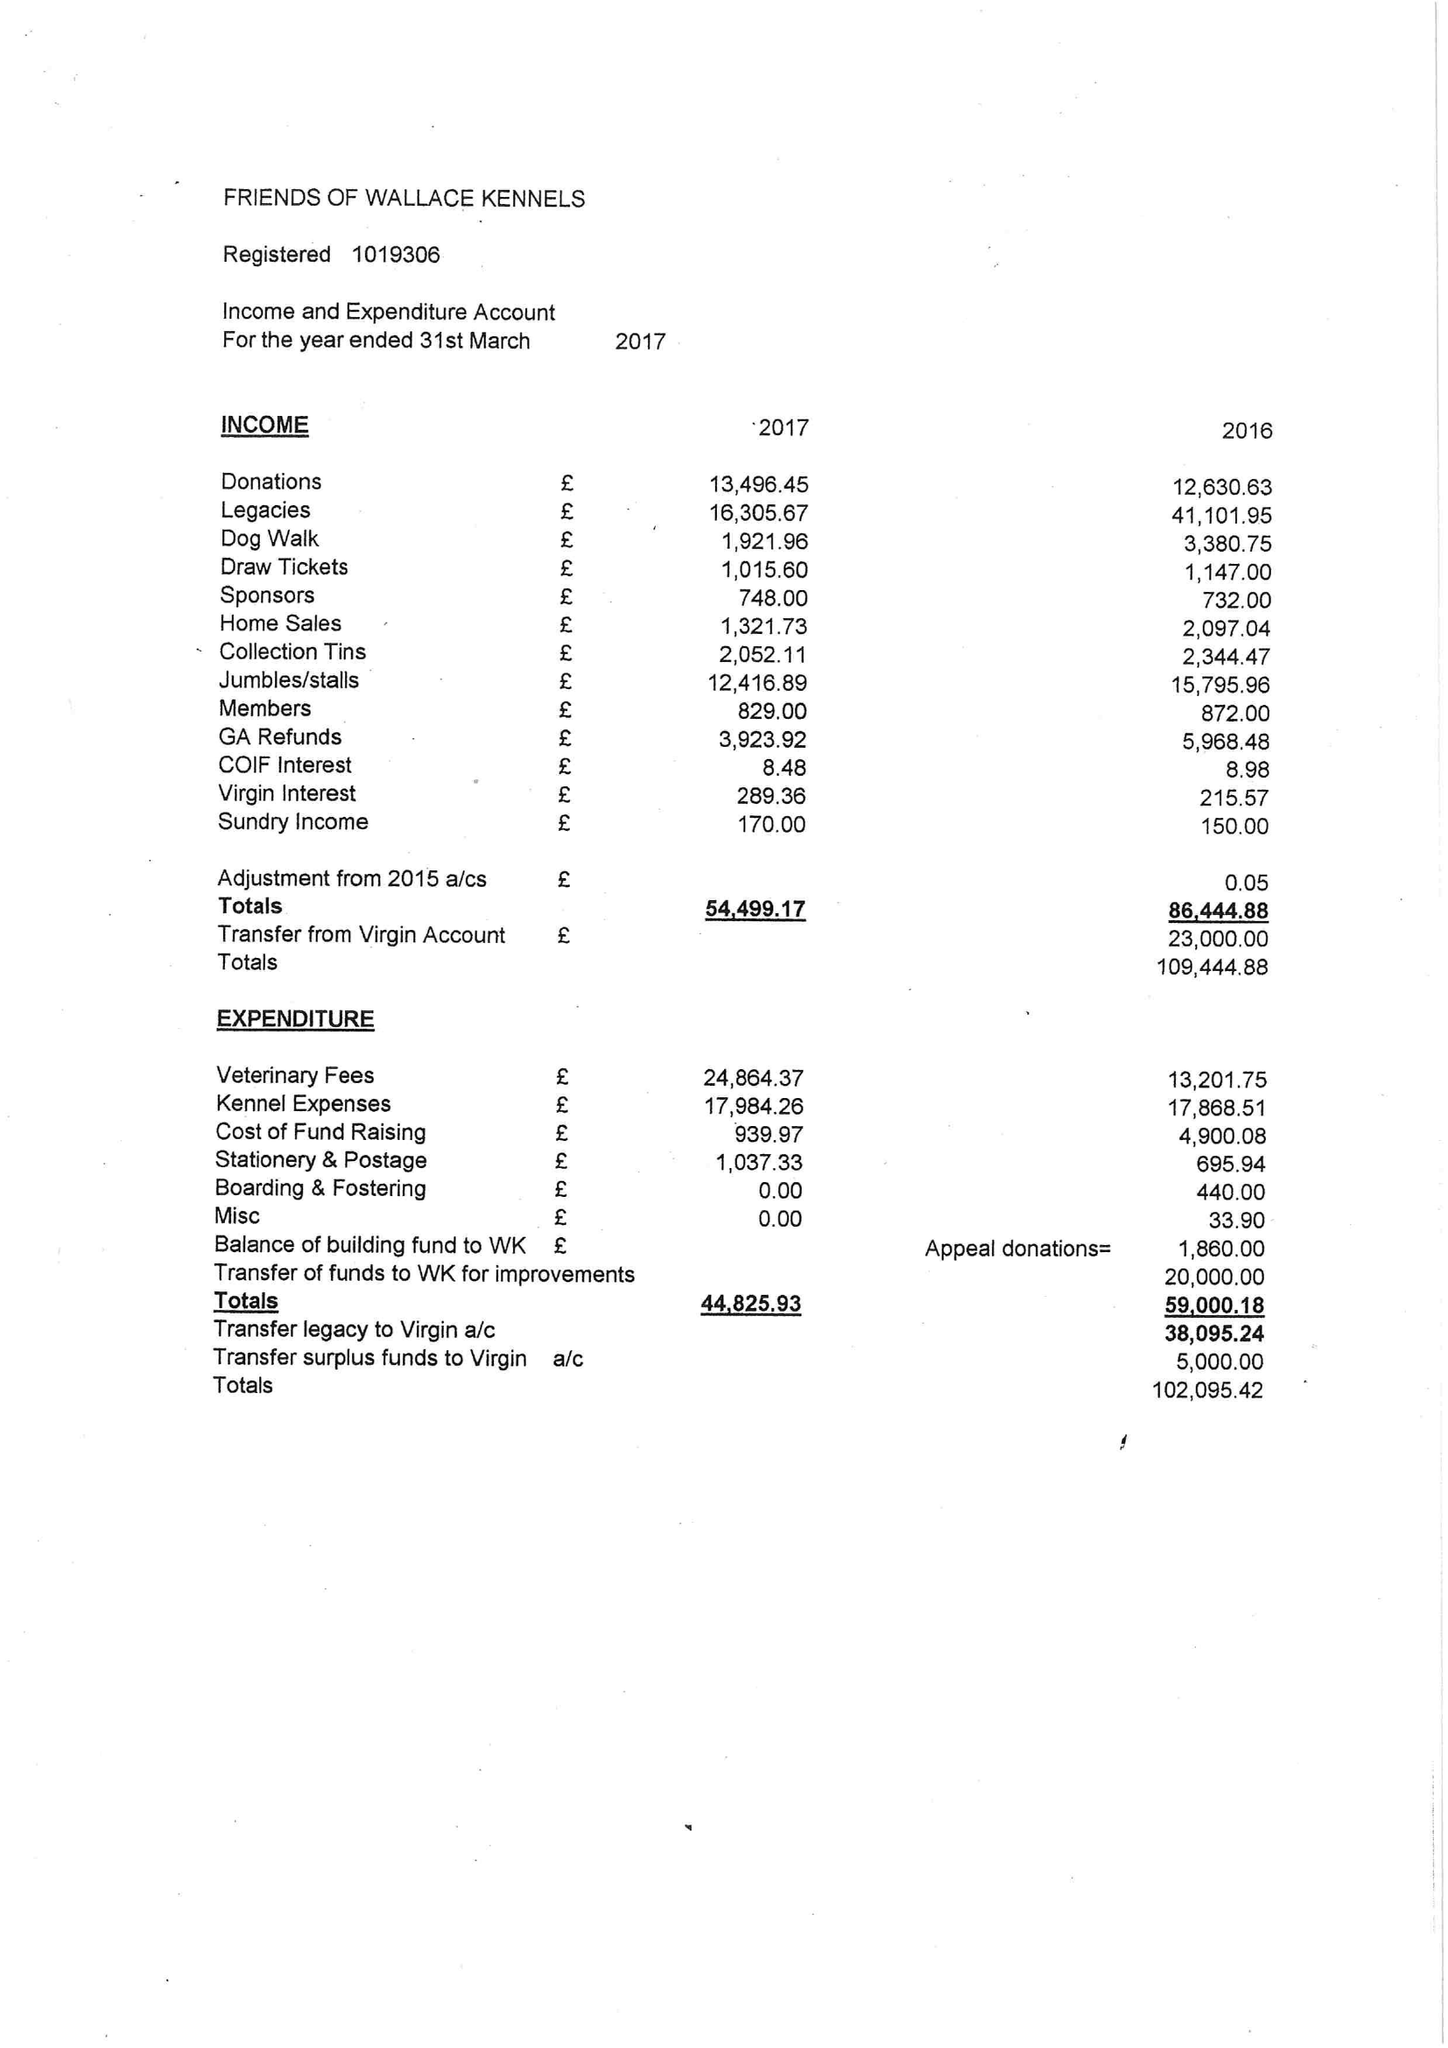What is the value for the report_date?
Answer the question using a single word or phrase. 2017-03-31 